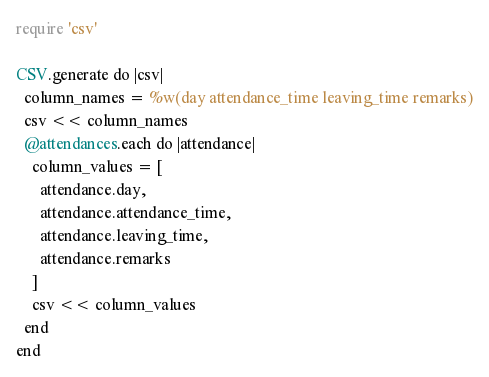<code> <loc_0><loc_0><loc_500><loc_500><_Ruby_>require 'csv'

CSV.generate do |csv|
  column_names = %w(day attendance_time leaving_time remarks)
  csv << column_names
  @attendances.each do |attendance|
    column_values = [
      attendance.day,
      attendance.attendance_time,
      attendance.leaving_time,
      attendance.remarks
    ]
    csv << column_values
  end
end</code> 